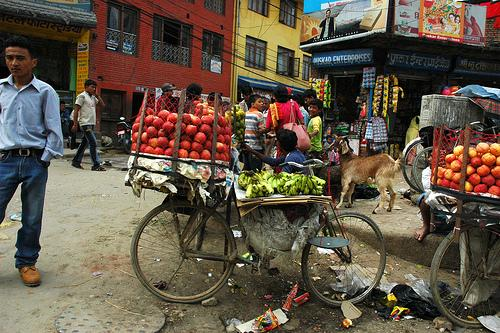Write a brief report detailing the current situation depicted in the image. At the busy marketplace, a man in a blue shirt and brown boots appears to be browsing various stalls. Among the items on display are a bicycle loaded with fruit, a goat, and an assortment of fruits such as bananas and apples. Explain the setting and main focus of the image in the form of a question. What do you see in this marketplace scene, where a man in a blue shirt stands amidst a bicycle carrying fruit, a goat, and various fruits like apples and bananas? Pretend you are the man in the image and describe what you see around you. As I stand here in my blue shirt, I see a market bustling with life - a goat nearby, a bicycle laden with fruit, and a variety of fruits all around me, like bananas and apples. Compose a short poetic verse that illustrates the essence of the image. Goat and bicycle in the light. Describe the image using only verbs and nouns. Man wearing. Blue shirt. Brown boots. Marketplace. Bicycle holding. Fruit. Goat. Bananas. Apples. Narrate a brief story using the elements of the image as inspiration. Once upon a time, a man wearing a blue shirt and brown boots ventured into a colorful marketplace filled with fresh fruits, goats, and other delights. The man's eyes widened at the fascinating sight of a bicycle loaded with fruit and couldn't resist the temptation to buy some apples and bananas for his journey home. In one sentence, describe the key elements of the image. The image captures a man wearing a blue shirt at a bustling market scene, with a goat, fruit-laden bicycle, and numerous types of fruit. Describe the main components of the image in a casual and informal tone. Hey, so there's this dude in a blue shirt, and he's hanging out at a market with all sorts of stuff around. Like, there's a goat, a bike holding lots of fruit, and even bananas and apples everywhere! Provide a concise description of the primary scene in the image. A man wearing a blue shirt and brown boots is surrounded by a marketplace, with a fruit-laden bicycle, goat, and various fruits in the background. Provide a description of the main subject's clothes and the surroundings in the image. The man in the image is wearing a blue shirt, blue jeans, a black belt and brown boots in a marketplace filled with fresh fruits loaded on a bicycle, a goat, and various types of fruits on display. 